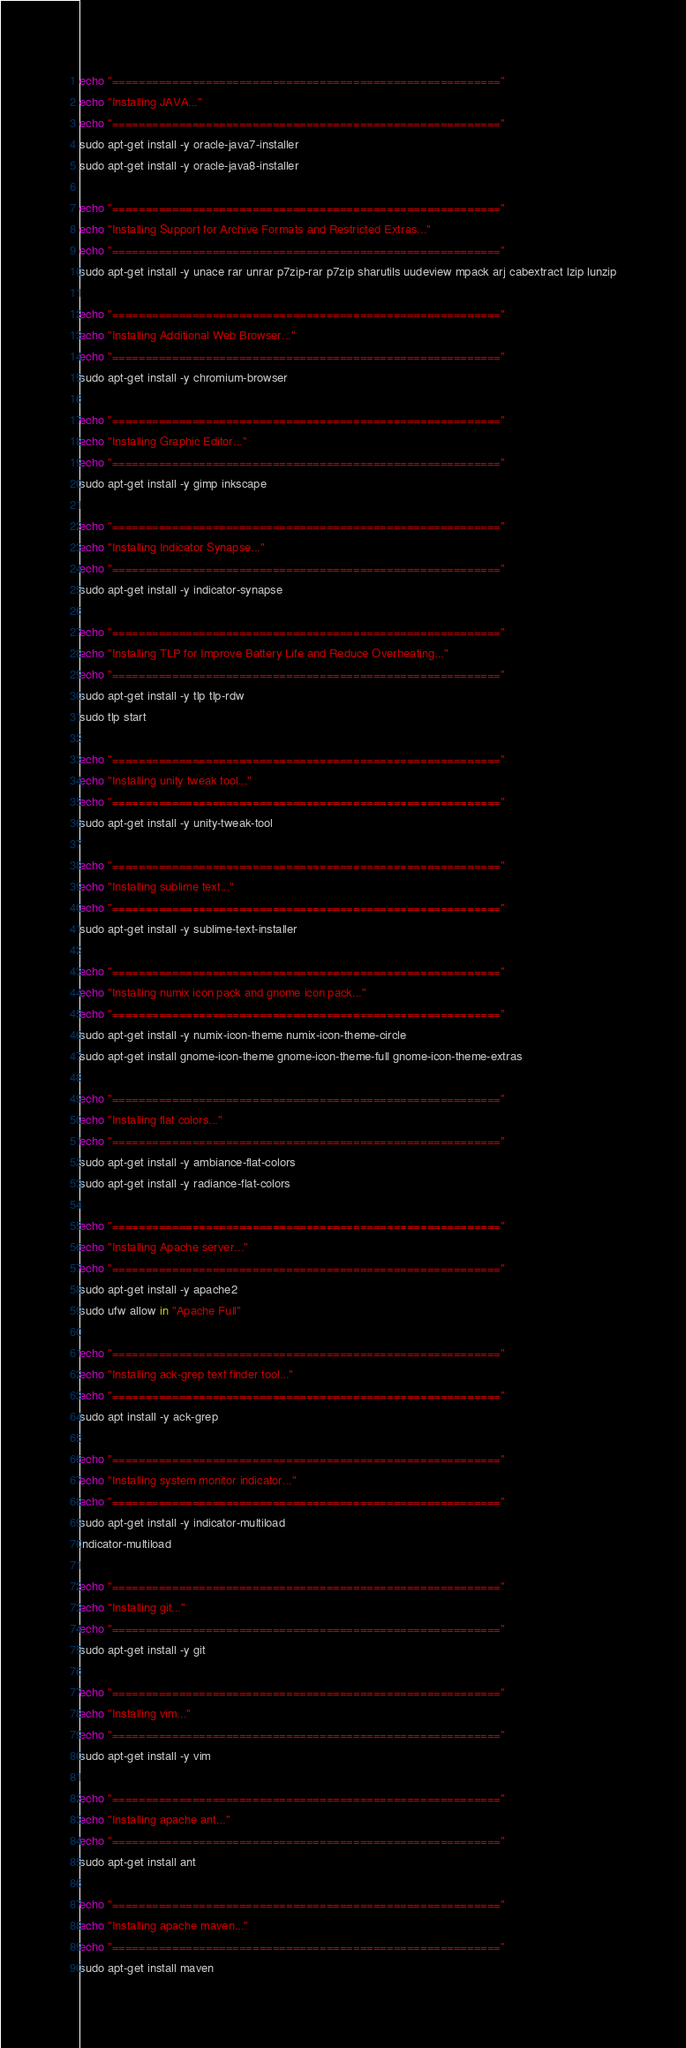Convert code to text. <code><loc_0><loc_0><loc_500><loc_500><_Bash_>echo "=========================================================="
echo "Installing JAVA..."
echo "=========================================================="
sudo apt-get install -y oracle-java7-installer
sudo apt-get install -y oracle-java8-installer

echo "=========================================================="
echo "Installing Support for Archive Formats and Restricted Extras..."
echo "=========================================================="
sudo apt-get install -y unace rar unrar p7zip-rar p7zip sharutils uudeview mpack arj cabextract lzip lunzip

echo "=========================================================="
echo "Installing Additional Web Browser..."
echo "=========================================================="
sudo apt-get install -y chromium-browser

echo "=========================================================="
echo "Installing Graphic Editor..."
echo "=========================================================="
sudo apt-get install -y gimp inkscape

echo "=========================================================="
echo "Installing Indicator Synapse..."
echo "=========================================================="
sudo apt-get install -y indicator-synapse

echo "=========================================================="
echo "Installing TLP for Improve Battery Life and Reduce Overheating..."
echo "=========================================================="
sudo apt-get install -y tlp tlp-rdw
sudo tlp start

echo "=========================================================="
echo "Installing unity tweak tool..."
echo "=========================================================="
sudo apt-get install -y unity-tweak-tool

echo "=========================================================="
echo "Installing sublime text..."
echo "=========================================================="
sudo apt-get install -y sublime-text-installer 

echo "=========================================================="
echo "Installing numix icon pack and gnome icon pack..."   
echo "=========================================================="
sudo apt-get install -y numix-icon-theme numix-icon-theme-circle
sudo apt-get install gnome-icon-theme gnome-icon-theme-full gnome-icon-theme-extras

echo "=========================================================="
echo "Installing flat colors..."
echo "=========================================================="
sudo apt-get install -y ambiance-flat-colors
sudo apt-get install -y radiance-flat-colors

echo "=========================================================="
echo "Installing Apache server..."
echo "=========================================================="
sudo apt-get install -y apache2
sudo ufw allow in "Apache Full"

echo "=========================================================="
echo "Installing ack-grep text finder tool..."
echo "=========================================================="
sudo apt install -y ack-grep

echo "=========================================================="
echo "Installing system monitor indicator..."
echo "=========================================================="
sudo apt-get install -y indicator-multiload
indicator-multiload

echo "=========================================================="
echo "Installing git..."
echo "=========================================================="
sudo apt-get install -y git

echo "=========================================================="
echo "Installing vim..."
echo "=========================================================="
sudo apt-get install -y vim

echo "=========================================================="
echo "Installing apache ant..."
echo "=========================================================="
sudo apt-get install ant

echo "=========================================================="
echo "Installing apache maven..."
echo "=========================================================="
sudo apt-get install maven


</code> 